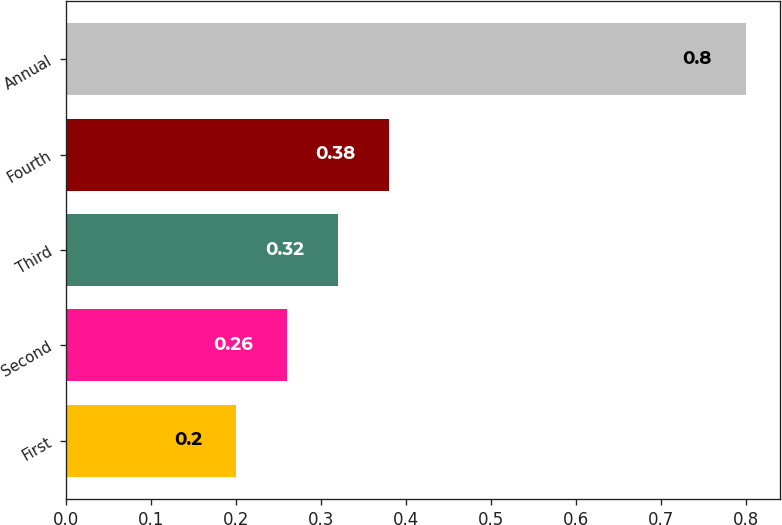<chart> <loc_0><loc_0><loc_500><loc_500><bar_chart><fcel>First<fcel>Second<fcel>Third<fcel>Fourth<fcel>Annual<nl><fcel>0.2<fcel>0.26<fcel>0.32<fcel>0.38<fcel>0.8<nl></chart> 